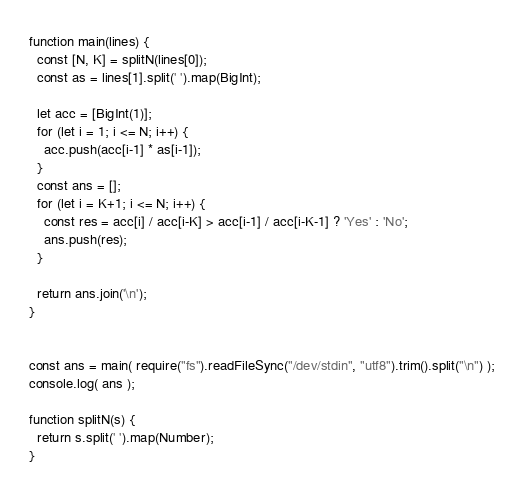Convert code to text. <code><loc_0><loc_0><loc_500><loc_500><_JavaScript_>function main(lines) {
  const [N, K] = splitN(lines[0]);
  const as = lines[1].split(' ').map(BigInt);

  let acc = [BigInt(1)];
  for (let i = 1; i <= N; i++) {
    acc.push(acc[i-1] * as[i-1]);
  }
  const ans = [];
  for (let i = K+1; i <= N; i++) {
    const res = acc[i] / acc[i-K] > acc[i-1] / acc[i-K-1] ? 'Yes' : 'No';
    ans.push(res);
  }
  
  return ans.join('\n');
}


const ans = main( require("fs").readFileSync("/dev/stdin", "utf8").trim().split("\n") );
console.log( ans );

function splitN(s) {
  return s.split(' ').map(Number);
}</code> 